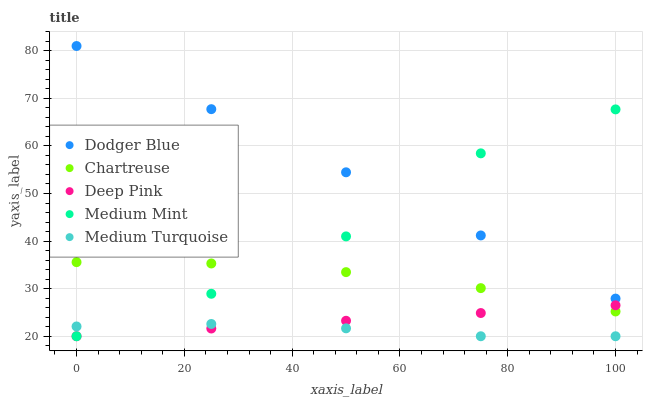Does Medium Turquoise have the minimum area under the curve?
Answer yes or no. Yes. Does Dodger Blue have the maximum area under the curve?
Answer yes or no. Yes. Does Chartreuse have the minimum area under the curve?
Answer yes or no. No. Does Chartreuse have the maximum area under the curve?
Answer yes or no. No. Is Deep Pink the smoothest?
Answer yes or no. Yes. Is Medium Mint the roughest?
Answer yes or no. Yes. Is Chartreuse the smoothest?
Answer yes or no. No. Is Chartreuse the roughest?
Answer yes or no. No. Does Medium Mint have the lowest value?
Answer yes or no. Yes. Does Chartreuse have the lowest value?
Answer yes or no. No. Does Dodger Blue have the highest value?
Answer yes or no. Yes. Does Chartreuse have the highest value?
Answer yes or no. No. Is Medium Turquoise less than Dodger Blue?
Answer yes or no. Yes. Is Dodger Blue greater than Deep Pink?
Answer yes or no. Yes. Does Deep Pink intersect Chartreuse?
Answer yes or no. Yes. Is Deep Pink less than Chartreuse?
Answer yes or no. No. Is Deep Pink greater than Chartreuse?
Answer yes or no. No. Does Medium Turquoise intersect Dodger Blue?
Answer yes or no. No. 